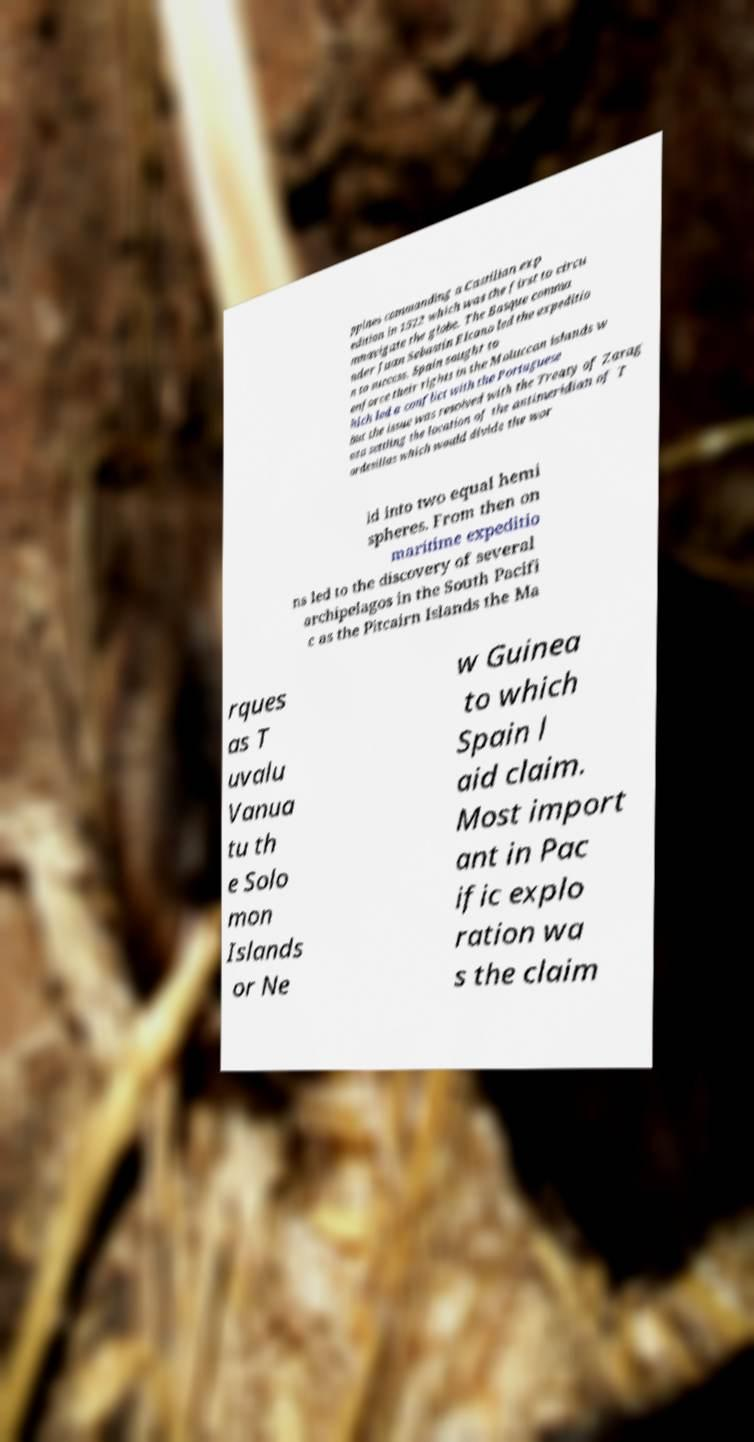I need the written content from this picture converted into text. Can you do that? ppines commanding a Castilian exp edition in 1522 which was the first to circu mnavigate the globe. The Basque comma nder Juan Sebastin Elcano led the expeditio n to success. Spain sought to enforce their rights in the Moluccan islands w hich led a conflict with the Portuguese but the issue was resolved with the Treaty of Zarag oza settling the location of the antimeridian of T ordesillas which would divide the wor ld into two equal hemi spheres. From then on maritime expeditio ns led to the discovery of several archipelagos in the South Pacifi c as the Pitcairn Islands the Ma rques as T uvalu Vanua tu th e Solo mon Islands or Ne w Guinea to which Spain l aid claim. Most import ant in Pac ific explo ration wa s the claim 